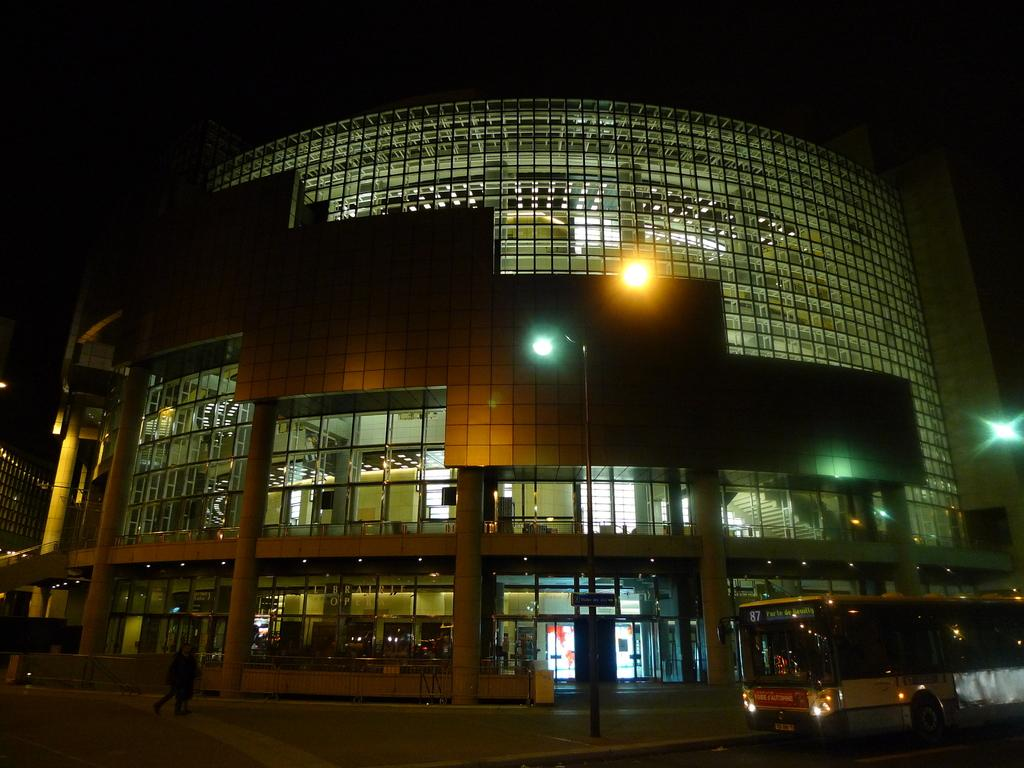What is the main subject of the picture? The main subject of the picture is a huge building. What type of organization might the building belong to? The building appears to be an organization, but the specific type is not mentioned in the facts. What are the people in the image doing? There are two people walking in front of the building. What else can be seen in the image? There is a bus on the right side of the image. What type of insect can be seen crawling on the building in the image? There is no insect visible on the building in the image. How many games are being played in the image? There is no indication of any games being played in the image. 